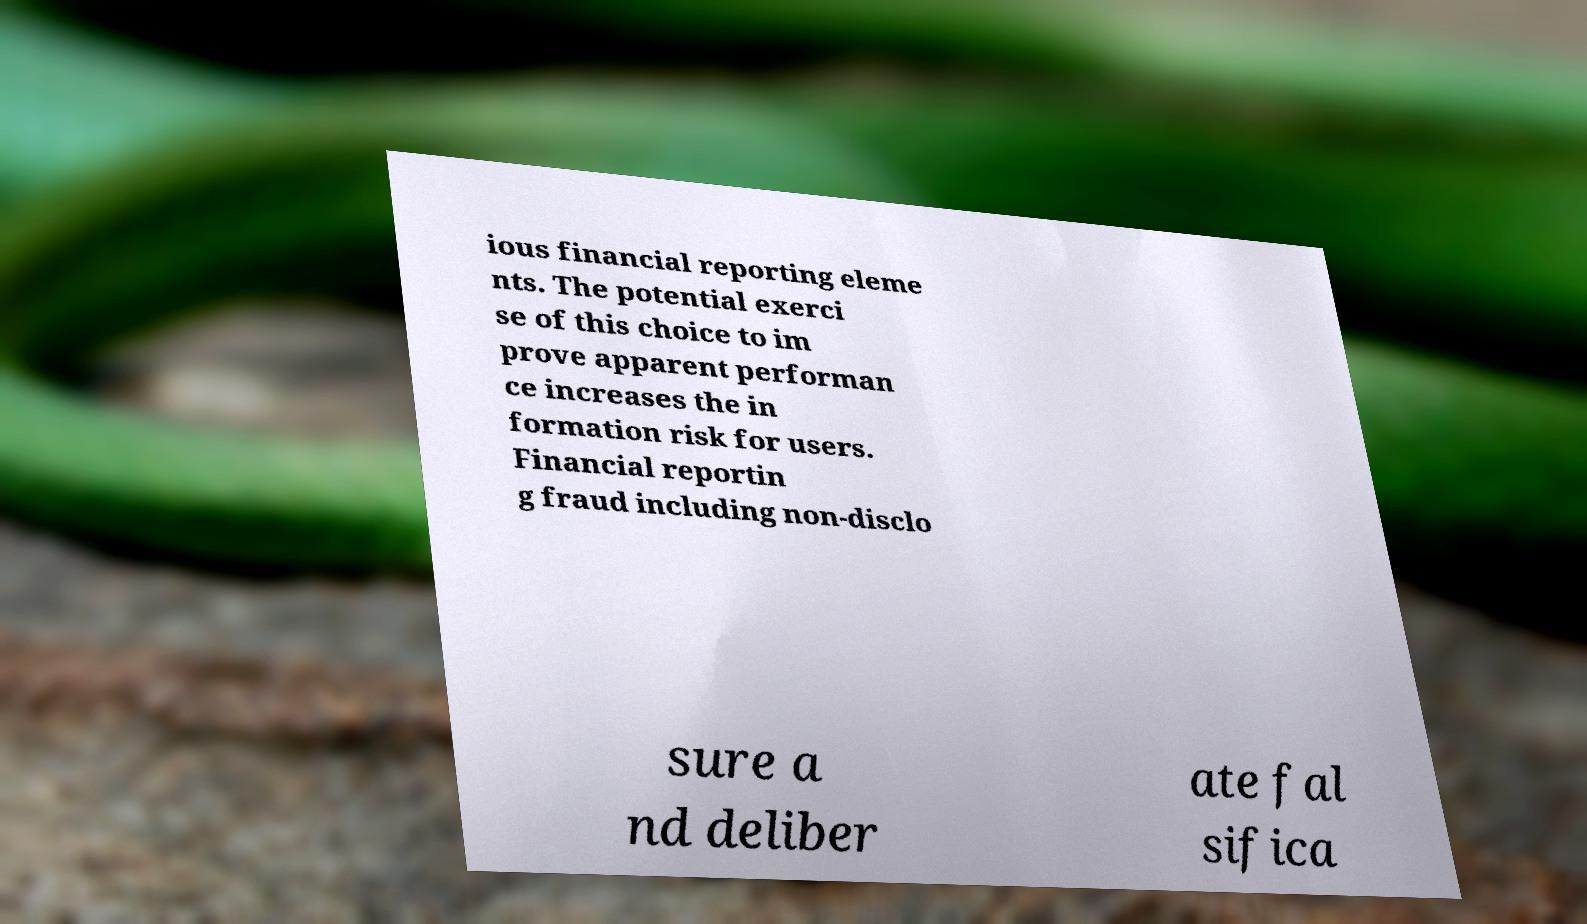I need the written content from this picture converted into text. Can you do that? ious financial reporting eleme nts. The potential exerci se of this choice to im prove apparent performan ce increases the in formation risk for users. Financial reportin g fraud including non-disclo sure a nd deliber ate fal sifica 